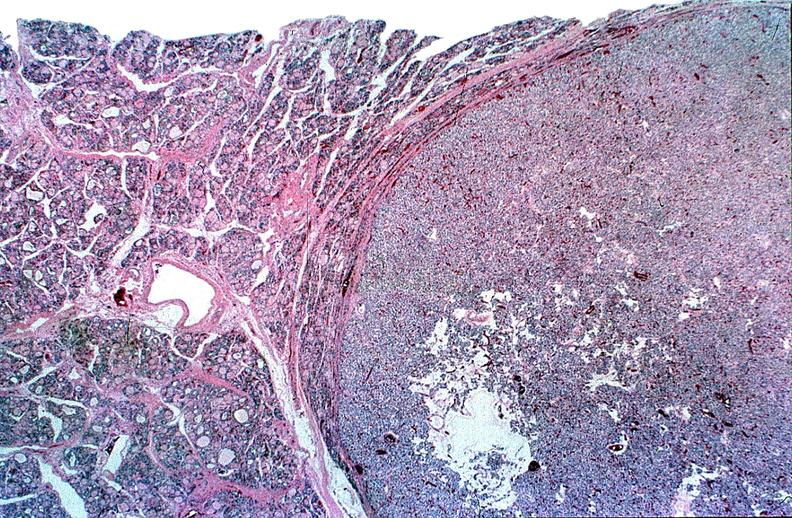s chest and abdomen slide present?
Answer the question using a single word or phrase. No 